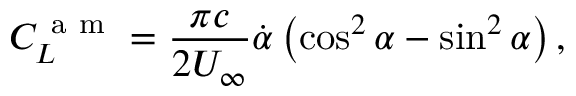<formula> <loc_0><loc_0><loc_500><loc_500>C _ { L } ^ { a m } = \frac { \pi c } { 2 U _ { \infty } } \dot { \alpha } \left ( \cos ^ { 2 } \alpha - \sin ^ { 2 } \alpha \right ) ,</formula> 